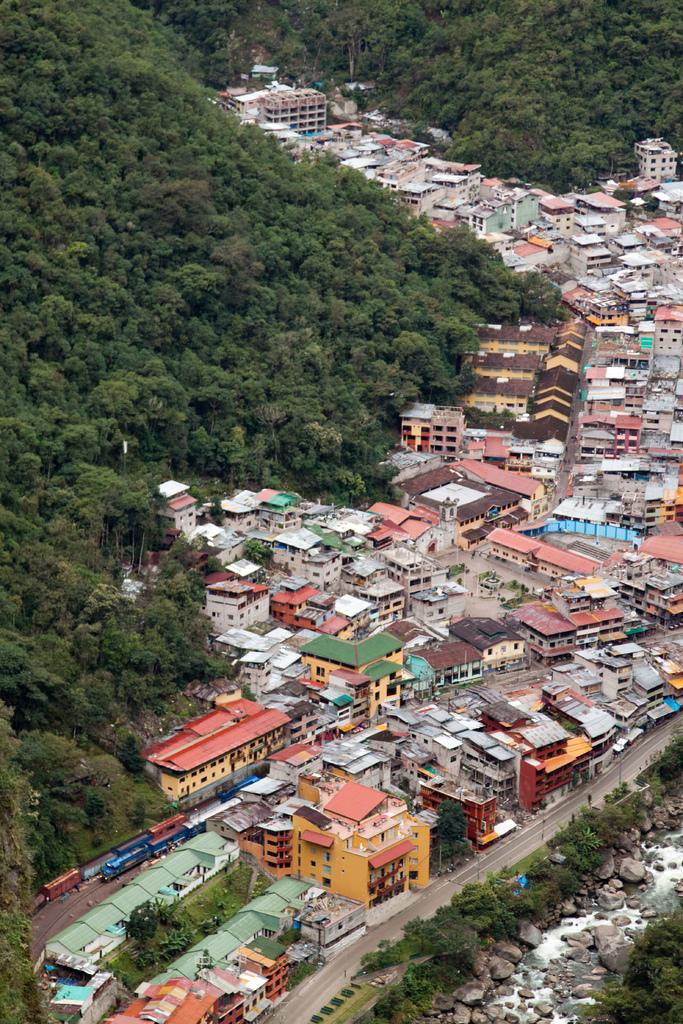What type of structures can be seen in the image? There are many houses and buildings in the image. What is located to the left of the image? There are trees to the left of the image. What can be found at the bottom of the image? There are rocks and water visible at the bottom of the image. What type of book is being read by the rocks in the image? There is no book present in the image, as it features houses, buildings, trees, rocks, and water. 